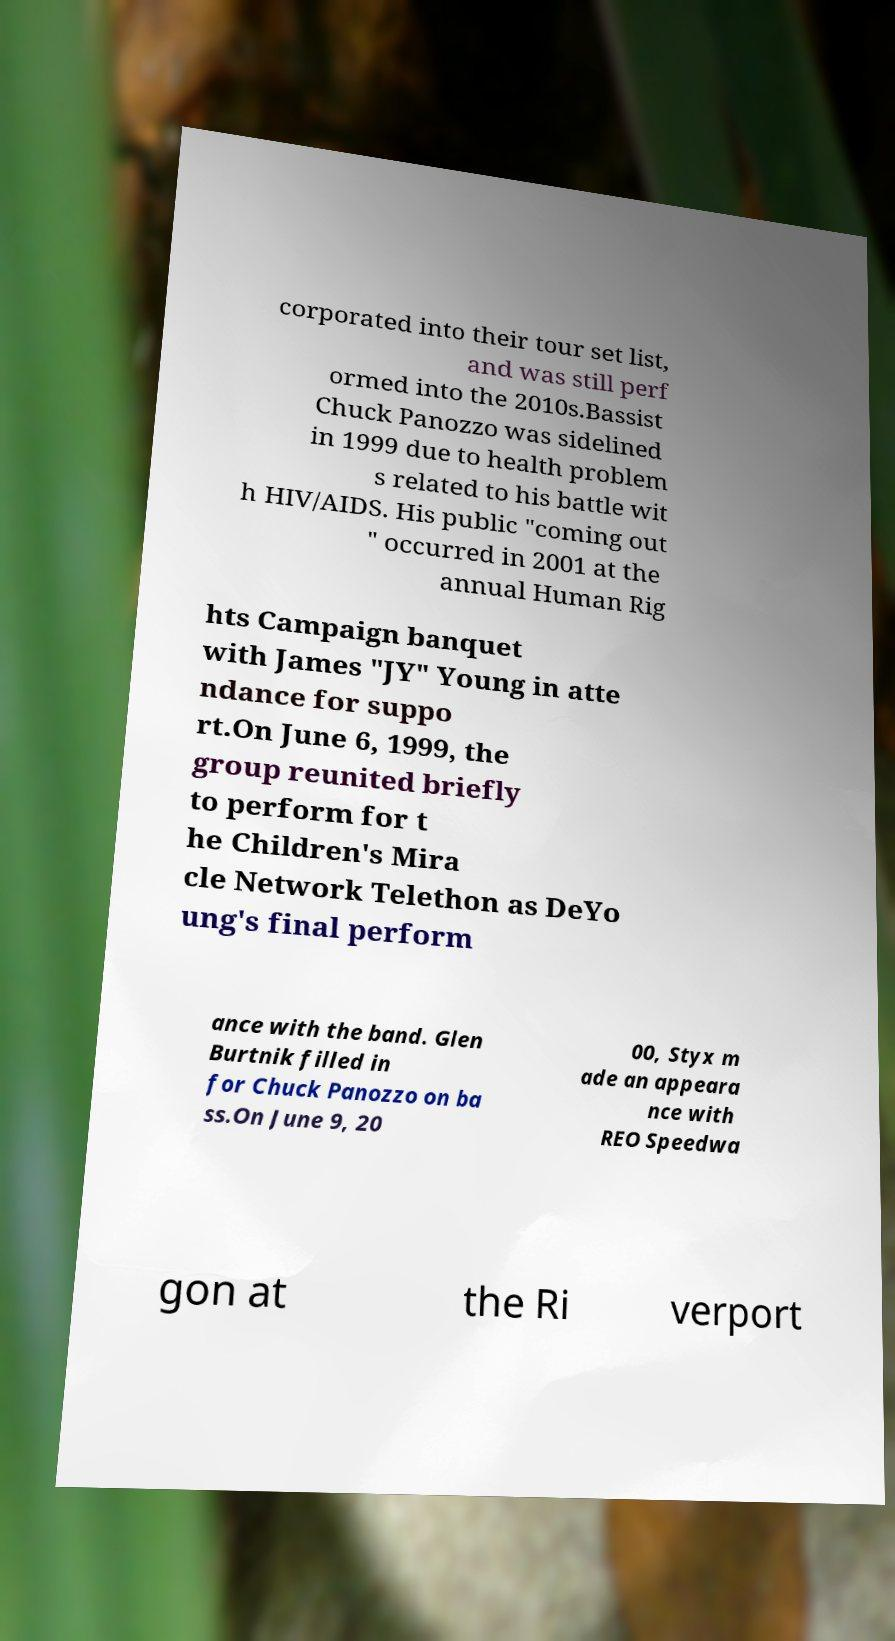There's text embedded in this image that I need extracted. Can you transcribe it verbatim? corporated into their tour set list, and was still perf ormed into the 2010s.Bassist Chuck Panozzo was sidelined in 1999 due to health problem s related to his battle wit h HIV/AIDS. His public "coming out " occurred in 2001 at the annual Human Rig hts Campaign banquet with James "JY" Young in atte ndance for suppo rt.On June 6, 1999, the group reunited briefly to perform for t he Children's Mira cle Network Telethon as DeYo ung's final perform ance with the band. Glen Burtnik filled in for Chuck Panozzo on ba ss.On June 9, 20 00, Styx m ade an appeara nce with REO Speedwa gon at the Ri verport 